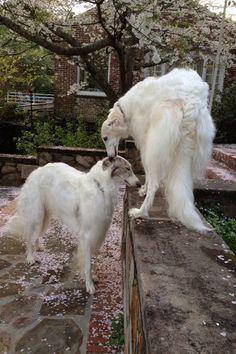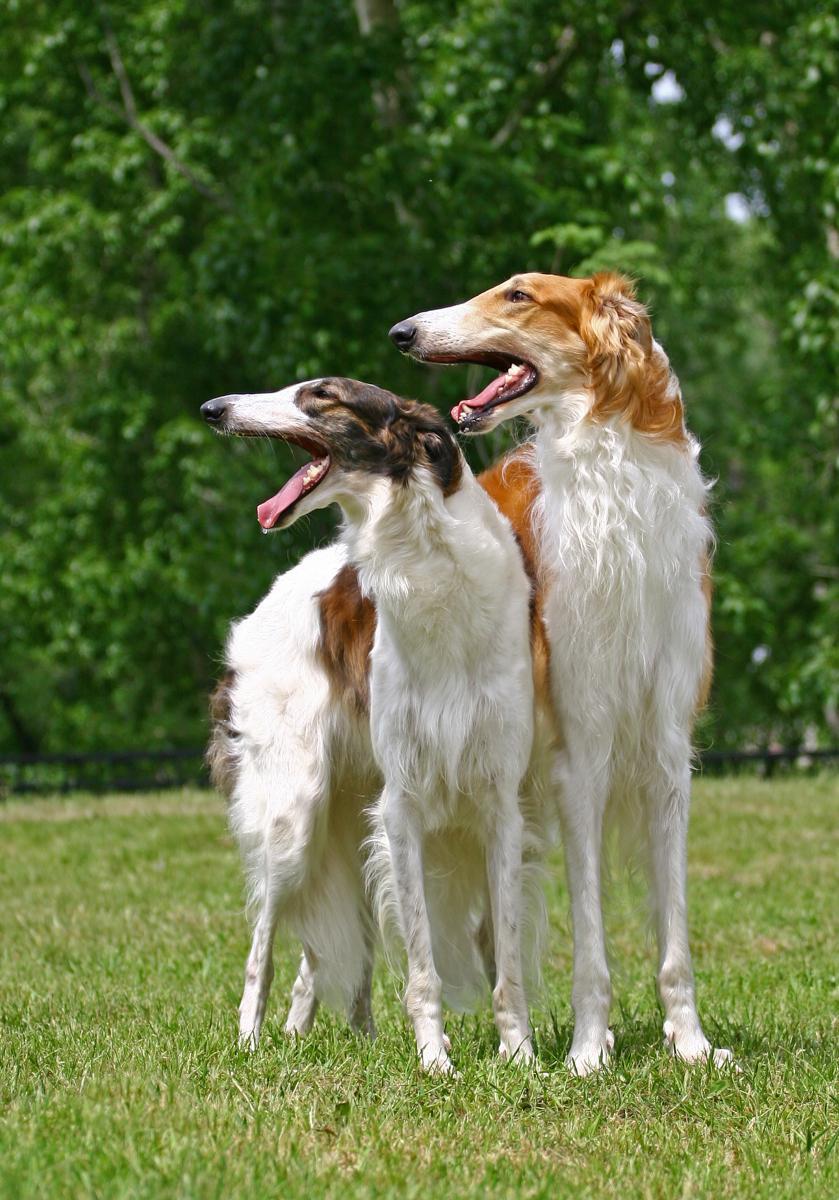The first image is the image on the left, the second image is the image on the right. Given the left and right images, does the statement "An image shows two hounds with faces turned inward, toward each other, and one with its head above the other." hold true? Answer yes or no. Yes. The first image is the image on the left, the second image is the image on the right. For the images displayed, is the sentence "Two dogs are running together in a field of grass." factually correct? Answer yes or no. No. 